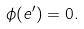Convert formula to latex. <formula><loc_0><loc_0><loc_500><loc_500>\phi ( e ^ { \prime } ) = 0 .</formula> 